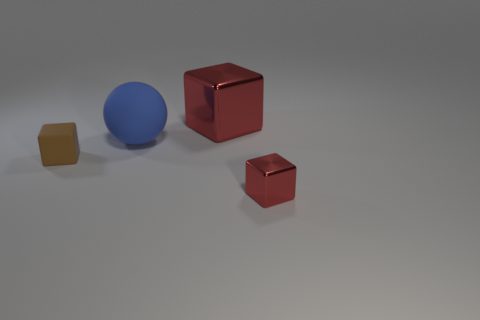Add 4 brown objects. How many objects exist? 8 Subtract all cubes. How many objects are left? 1 Subtract all red shiny cubes. How many cubes are left? 1 Subtract 0 brown balls. How many objects are left? 4 Subtract 1 spheres. How many spheres are left? 0 Subtract all cyan cubes. Subtract all cyan balls. How many cubes are left? 3 Subtract all brown balls. How many brown blocks are left? 1 Subtract all cyan matte objects. Subtract all large spheres. How many objects are left? 3 Add 3 red metal things. How many red metal things are left? 5 Add 2 metal balls. How many metal balls exist? 2 